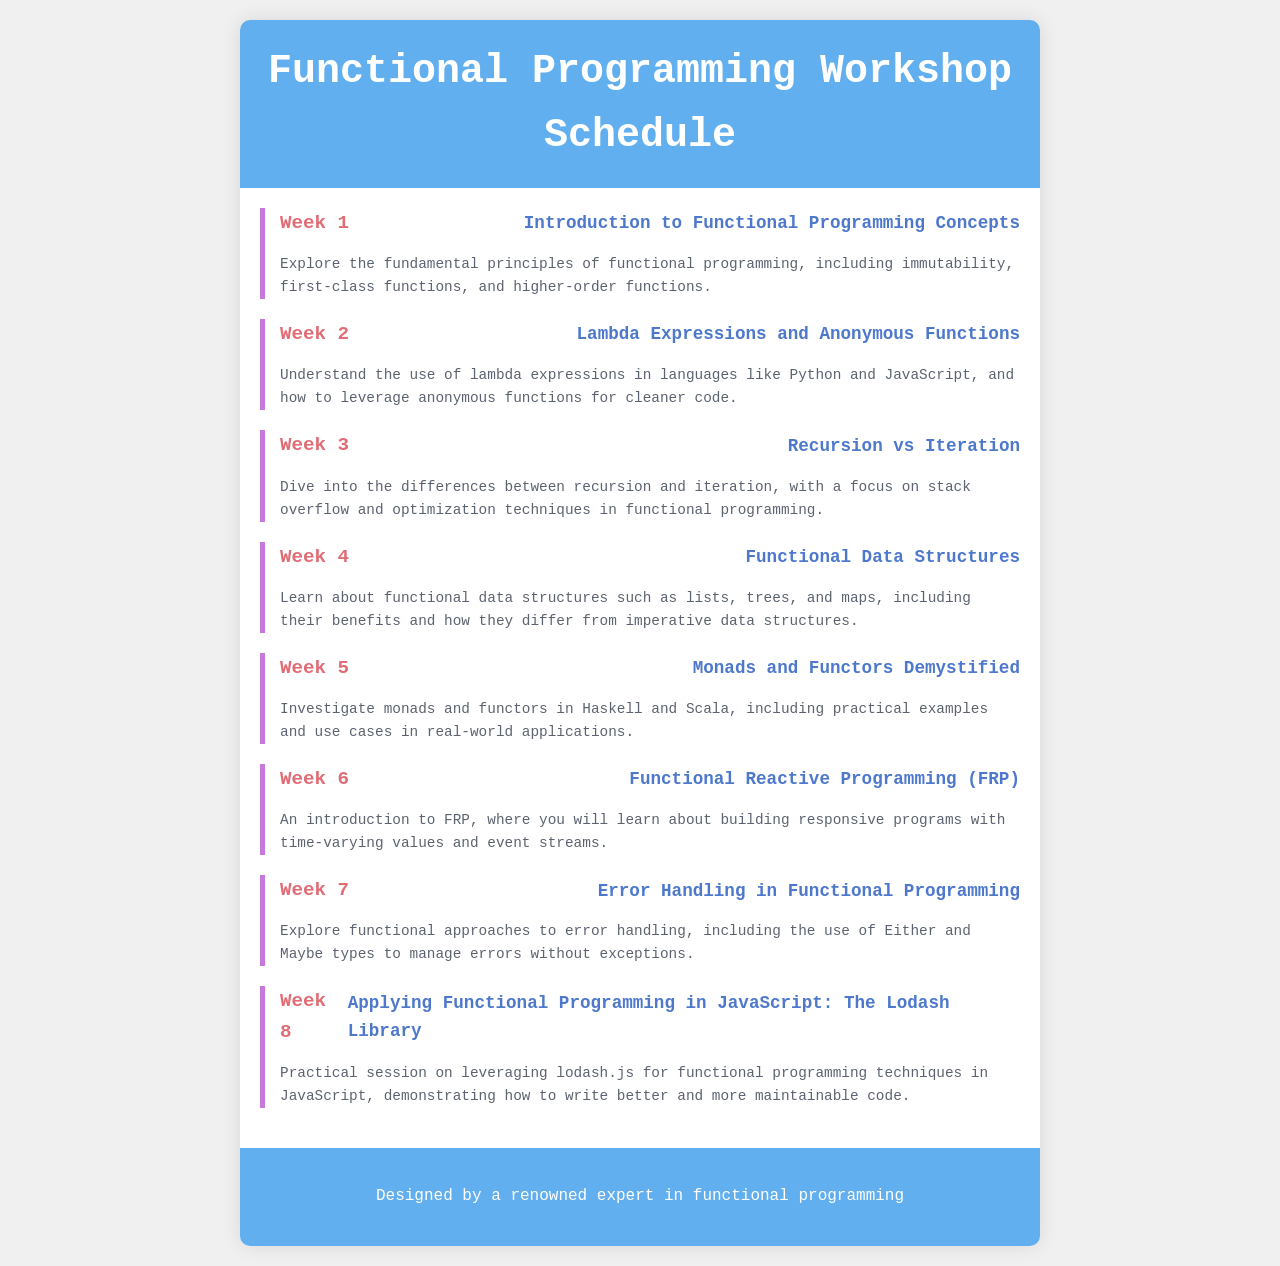What is the title of the document? The title of the document is stated in the <title> tag of the HTML, which is about the schedule.
Answer: Functional Programming Workshop Schedule How many weeks are covered in the workshop? The total number of weeks is represented by the number of "week" sections in the document.
Answer: 8 What is the topic of Week 3? The topic for Week 3 is identified in the week header corresponding to Week 3.
Answer: Recursion vs Iteration What is the main focus of the workshop in Week 5? The main focus of Week 5 addresses specific functional programming concepts listed under the topic.
Answer: Monads and Functors Demystified Which week covers Functional Reactive Programming? The week dedicated to Functional Reactive Programming can be found by searching for the topic in the document.
Answer: Week 6 What type of error handling is discussed in Week 7? The description for Week 7 mentions specific approaches to error management in functional programming.
Answer: Either and Maybe types Which library is mentioned for applying functional programming in JavaScript? The relevant library for JavaScript is specified in the topic of Week 8, highlighting functional programming techniques.
Answer: Lodash Library What color is the header background? The color of the header background is described in the CSS style section of the document.
Answer: #61afef 